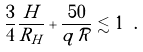Convert formula to latex. <formula><loc_0><loc_0><loc_500><loc_500>\frac { 3 } { 4 } \frac { H } { R _ { H } } + \frac { 5 0 } { q \mathcal { R } } \lesssim 1 \ .</formula> 